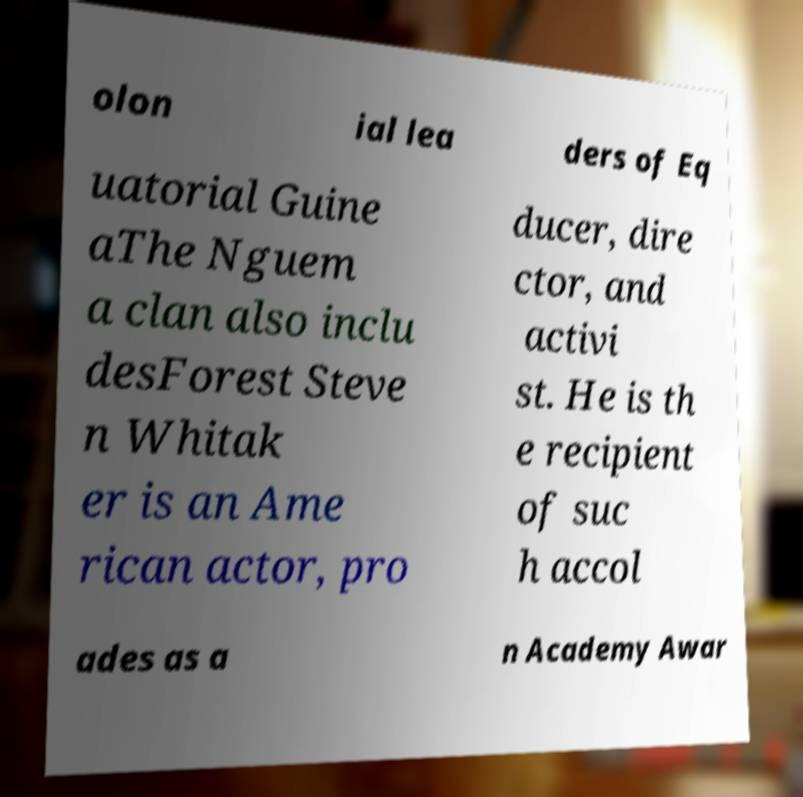Please read and relay the text visible in this image. What does it say? olon ial lea ders of Eq uatorial Guine aThe Nguem a clan also inclu desForest Steve n Whitak er is an Ame rican actor, pro ducer, dire ctor, and activi st. He is th e recipient of suc h accol ades as a n Academy Awar 